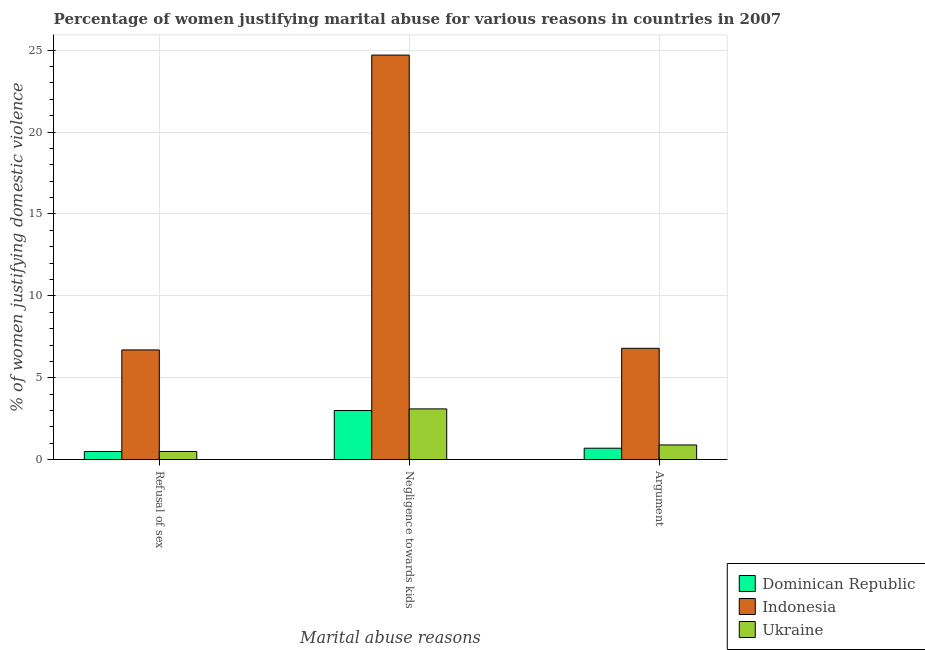How many different coloured bars are there?
Offer a very short reply. 3. How many groups of bars are there?
Offer a terse response. 3. Are the number of bars on each tick of the X-axis equal?
Your answer should be very brief. Yes. How many bars are there on the 3rd tick from the right?
Offer a terse response. 3. What is the label of the 2nd group of bars from the left?
Ensure brevity in your answer.  Negligence towards kids. What is the percentage of women justifying domestic violence due to negligence towards kids in Ukraine?
Offer a terse response. 3.1. Across all countries, what is the maximum percentage of women justifying domestic violence due to negligence towards kids?
Your answer should be compact. 24.7. Across all countries, what is the minimum percentage of women justifying domestic violence due to refusal of sex?
Give a very brief answer. 0.5. In which country was the percentage of women justifying domestic violence due to arguments minimum?
Your answer should be very brief. Dominican Republic. What is the total percentage of women justifying domestic violence due to negligence towards kids in the graph?
Ensure brevity in your answer.  30.8. What is the difference between the percentage of women justifying domestic violence due to negligence towards kids in Dominican Republic and that in Ukraine?
Ensure brevity in your answer.  -0.1. What is the difference between the percentage of women justifying domestic violence due to arguments in Indonesia and the percentage of women justifying domestic violence due to negligence towards kids in Ukraine?
Your response must be concise. 3.7. What is the average percentage of women justifying domestic violence due to negligence towards kids per country?
Make the answer very short. 10.27. What is the difference between the percentage of women justifying domestic violence due to negligence towards kids and percentage of women justifying domestic violence due to arguments in Dominican Republic?
Your answer should be very brief. 2.3. In how many countries, is the percentage of women justifying domestic violence due to arguments greater than 23 %?
Offer a very short reply. 0. What is the ratio of the percentage of women justifying domestic violence due to arguments in Ukraine to that in Indonesia?
Offer a very short reply. 0.13. Is the percentage of women justifying domestic violence due to refusal of sex in Indonesia less than that in Dominican Republic?
Give a very brief answer. No. What is the difference between the highest and the second highest percentage of women justifying domestic violence due to arguments?
Your answer should be compact. 5.9. What is the difference between the highest and the lowest percentage of women justifying domestic violence due to arguments?
Keep it short and to the point. 6.1. In how many countries, is the percentage of women justifying domestic violence due to refusal of sex greater than the average percentage of women justifying domestic violence due to refusal of sex taken over all countries?
Your response must be concise. 1. Is the sum of the percentage of women justifying domestic violence due to arguments in Ukraine and Indonesia greater than the maximum percentage of women justifying domestic violence due to refusal of sex across all countries?
Your answer should be compact. Yes. What does the 1st bar from the left in Negligence towards kids represents?
Provide a short and direct response. Dominican Republic. What does the 3rd bar from the right in Refusal of sex represents?
Give a very brief answer. Dominican Republic. How many bars are there?
Make the answer very short. 9. How many countries are there in the graph?
Offer a terse response. 3. Are the values on the major ticks of Y-axis written in scientific E-notation?
Your response must be concise. No. Does the graph contain grids?
Keep it short and to the point. Yes. What is the title of the graph?
Provide a short and direct response. Percentage of women justifying marital abuse for various reasons in countries in 2007. What is the label or title of the X-axis?
Your answer should be very brief. Marital abuse reasons. What is the label or title of the Y-axis?
Keep it short and to the point. % of women justifying domestic violence. What is the % of women justifying domestic violence in Dominican Republic in Refusal of sex?
Make the answer very short. 0.5. What is the % of women justifying domestic violence of Dominican Republic in Negligence towards kids?
Ensure brevity in your answer.  3. What is the % of women justifying domestic violence in Indonesia in Negligence towards kids?
Make the answer very short. 24.7. What is the % of women justifying domestic violence of Ukraine in Negligence towards kids?
Provide a succinct answer. 3.1. What is the % of women justifying domestic violence in Indonesia in Argument?
Provide a succinct answer. 6.8. What is the % of women justifying domestic violence of Ukraine in Argument?
Give a very brief answer. 0.9. Across all Marital abuse reasons, what is the maximum % of women justifying domestic violence in Indonesia?
Provide a succinct answer. 24.7. Across all Marital abuse reasons, what is the minimum % of women justifying domestic violence of Dominican Republic?
Provide a succinct answer. 0.5. Across all Marital abuse reasons, what is the minimum % of women justifying domestic violence in Ukraine?
Keep it short and to the point. 0.5. What is the total % of women justifying domestic violence of Dominican Republic in the graph?
Ensure brevity in your answer.  4.2. What is the total % of women justifying domestic violence of Indonesia in the graph?
Offer a very short reply. 38.2. What is the total % of women justifying domestic violence in Ukraine in the graph?
Give a very brief answer. 4.5. What is the difference between the % of women justifying domestic violence in Dominican Republic in Refusal of sex and that in Negligence towards kids?
Your answer should be compact. -2.5. What is the difference between the % of women justifying domestic violence of Indonesia in Refusal of sex and that in Negligence towards kids?
Give a very brief answer. -18. What is the difference between the % of women justifying domestic violence of Ukraine in Negligence towards kids and that in Argument?
Your response must be concise. 2.2. What is the difference between the % of women justifying domestic violence in Dominican Republic in Refusal of sex and the % of women justifying domestic violence in Indonesia in Negligence towards kids?
Your answer should be very brief. -24.2. What is the difference between the % of women justifying domestic violence of Indonesia in Refusal of sex and the % of women justifying domestic violence of Ukraine in Negligence towards kids?
Offer a very short reply. 3.6. What is the difference between the % of women justifying domestic violence of Dominican Republic in Refusal of sex and the % of women justifying domestic violence of Indonesia in Argument?
Ensure brevity in your answer.  -6.3. What is the difference between the % of women justifying domestic violence in Dominican Republic in Refusal of sex and the % of women justifying domestic violence in Ukraine in Argument?
Give a very brief answer. -0.4. What is the difference between the % of women justifying domestic violence of Indonesia in Refusal of sex and the % of women justifying domestic violence of Ukraine in Argument?
Give a very brief answer. 5.8. What is the difference between the % of women justifying domestic violence of Dominican Republic in Negligence towards kids and the % of women justifying domestic violence of Indonesia in Argument?
Provide a short and direct response. -3.8. What is the difference between the % of women justifying domestic violence in Dominican Republic in Negligence towards kids and the % of women justifying domestic violence in Ukraine in Argument?
Keep it short and to the point. 2.1. What is the difference between the % of women justifying domestic violence of Indonesia in Negligence towards kids and the % of women justifying domestic violence of Ukraine in Argument?
Ensure brevity in your answer.  23.8. What is the average % of women justifying domestic violence of Indonesia per Marital abuse reasons?
Offer a terse response. 12.73. What is the average % of women justifying domestic violence of Ukraine per Marital abuse reasons?
Keep it short and to the point. 1.5. What is the difference between the % of women justifying domestic violence of Dominican Republic and % of women justifying domestic violence of Indonesia in Refusal of sex?
Provide a short and direct response. -6.2. What is the difference between the % of women justifying domestic violence of Dominican Republic and % of women justifying domestic violence of Ukraine in Refusal of sex?
Ensure brevity in your answer.  0. What is the difference between the % of women justifying domestic violence in Dominican Republic and % of women justifying domestic violence in Indonesia in Negligence towards kids?
Offer a very short reply. -21.7. What is the difference between the % of women justifying domestic violence of Indonesia and % of women justifying domestic violence of Ukraine in Negligence towards kids?
Provide a succinct answer. 21.6. What is the ratio of the % of women justifying domestic violence in Indonesia in Refusal of sex to that in Negligence towards kids?
Provide a short and direct response. 0.27. What is the ratio of the % of women justifying domestic violence in Ukraine in Refusal of sex to that in Negligence towards kids?
Provide a succinct answer. 0.16. What is the ratio of the % of women justifying domestic violence in Ukraine in Refusal of sex to that in Argument?
Ensure brevity in your answer.  0.56. What is the ratio of the % of women justifying domestic violence of Dominican Republic in Negligence towards kids to that in Argument?
Provide a succinct answer. 4.29. What is the ratio of the % of women justifying domestic violence in Indonesia in Negligence towards kids to that in Argument?
Your answer should be very brief. 3.63. What is the ratio of the % of women justifying domestic violence in Ukraine in Negligence towards kids to that in Argument?
Offer a terse response. 3.44. What is the difference between the highest and the second highest % of women justifying domestic violence in Indonesia?
Offer a very short reply. 17.9. What is the difference between the highest and the lowest % of women justifying domestic violence of Indonesia?
Give a very brief answer. 18. 